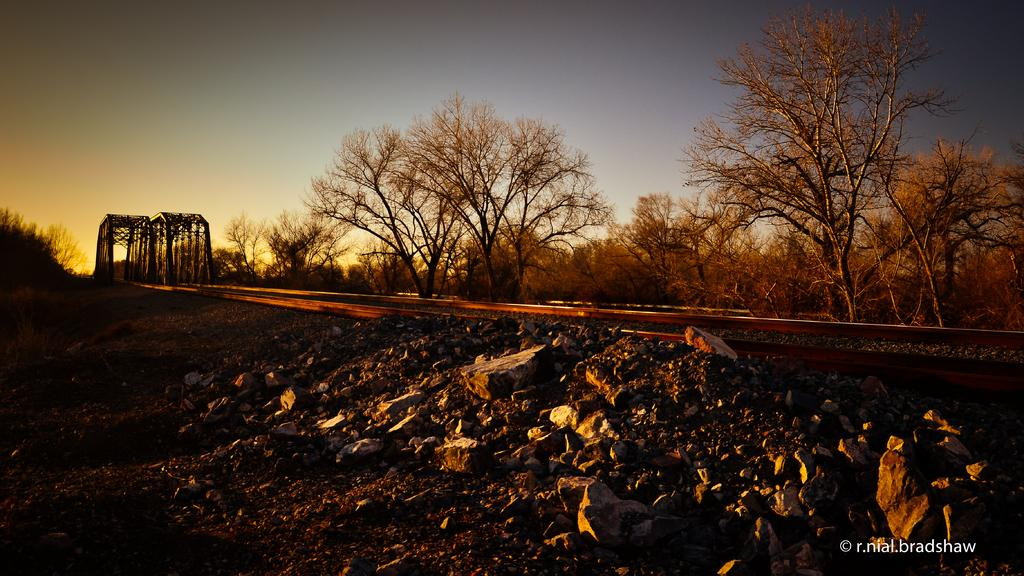What type of natural formation can be seen in the image? There are rocks in the image. What man-made structure is present in the image? There is a railway track in the image. What type of support structure is visible in the image? There are wooden poles in the image. What type of vegetation is present in the image? There are trees in the image. What part of the natural environment is visible in the image? The sky is visible in the image. Can you tell me how many oranges are hanging from the wooden poles in the image? There are no oranges present in the image; it features rocks, a railway track, wooden poles, trees, and the sky. What type of fruit is being bitten by someone in the image? There is no fruit being bitten in the image; it does not depict any people or animals. 